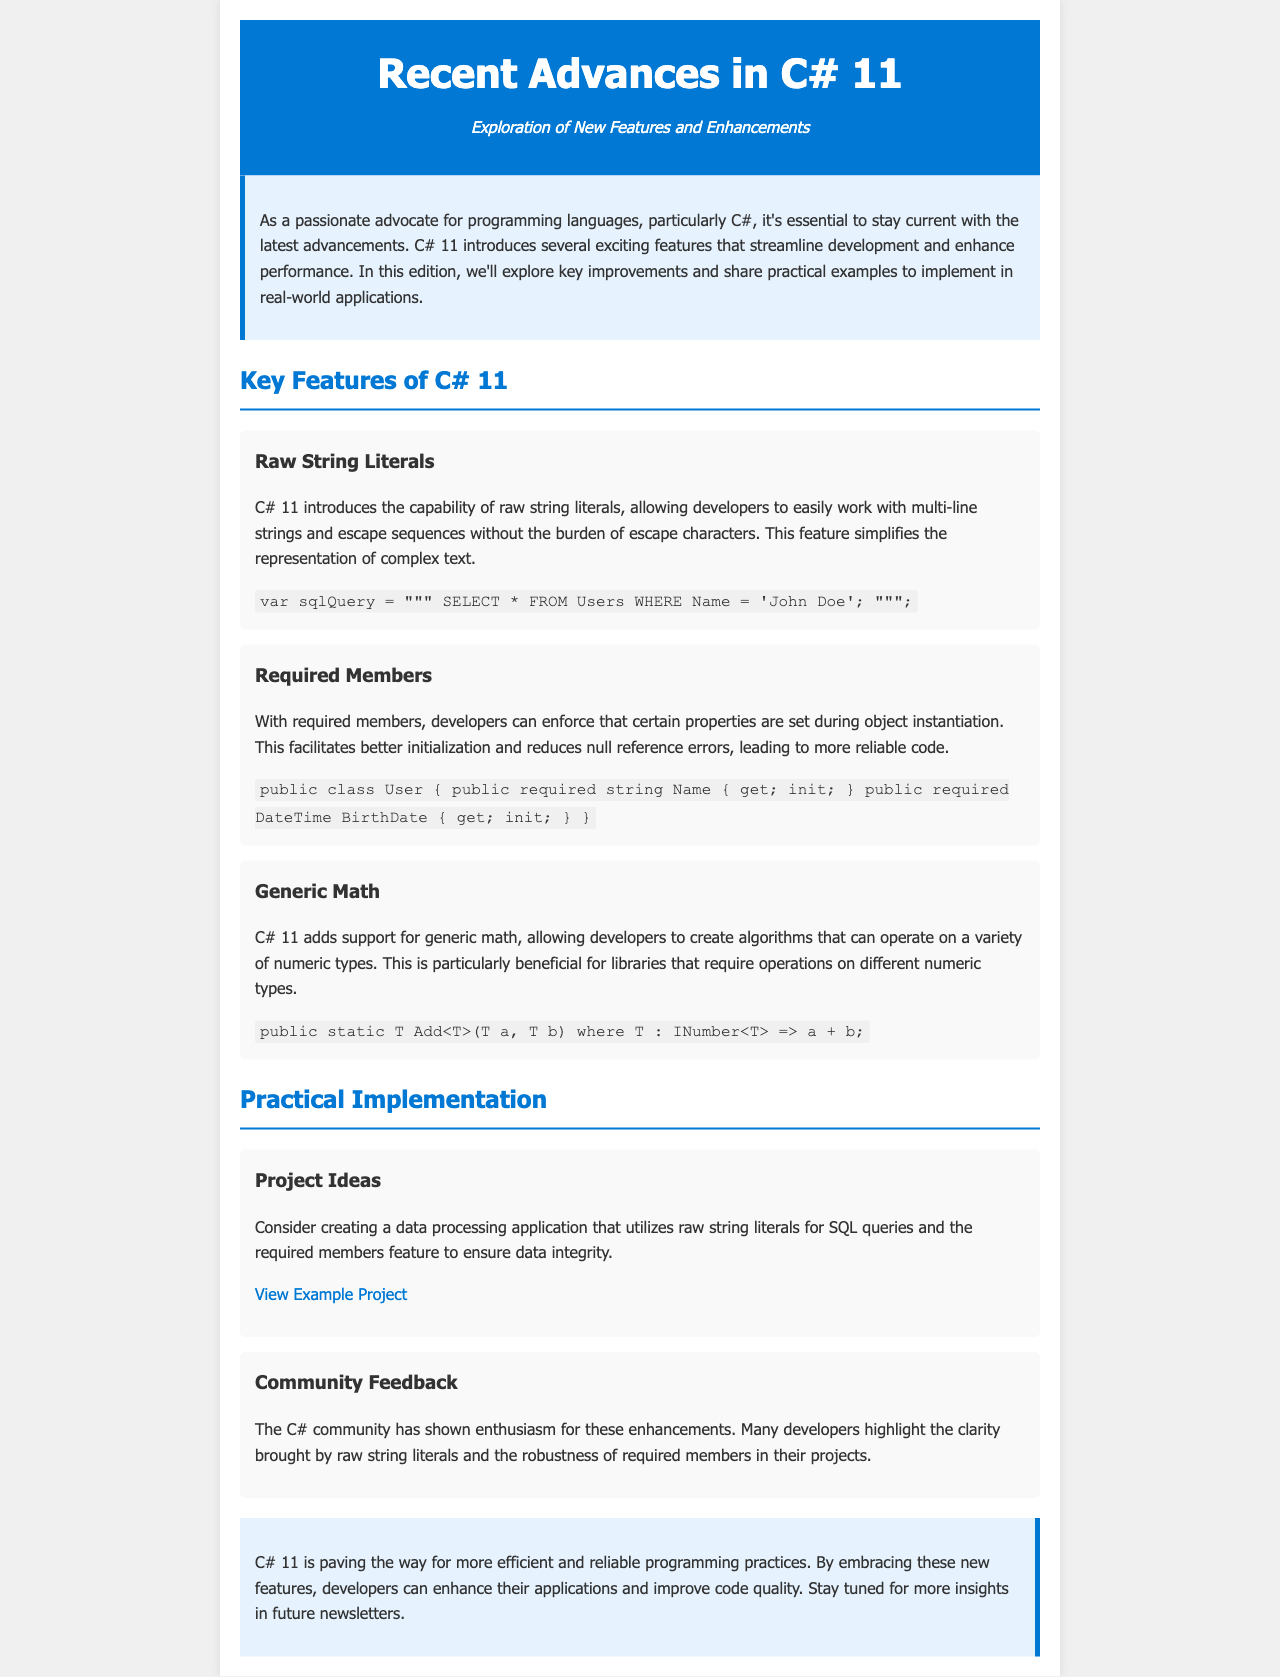What is the title of the newsletter? The title of the newsletter is located in the header section of the document.
Answer: Recent Advances in C# 11 What are raw string literals used for? The explanation of raw string literals is found in the corresponding feature section.
Answer: Multi-line strings What new feature helps reduce null reference errors? This question refers to the feature that enforces property initialization.
Answer: Required members What is an example of generic math introduced in C# 11? The example of generic math can be found in the respective feature section in code form.
Answer: T Add<T>(T a, T b) How does the C# community feel about the new features? The community feedback is summarized in the feedback section of the document.
Answer: Enthusiastic What is mentioned as a project idea utilizing C# 11 features? The project idea is located in the practical implementation section of the document.
Answer: Data processing application What color is used for the header background? The styling of the header background is described within the CSS section of the document.
Answer: Blue What is the main purpose of the newsletter? The introduction section outlines the main purpose of the newsletter.
Answer: Explore new features and enhancements 